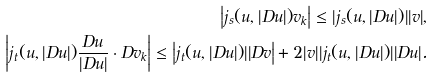Convert formula to latex. <formula><loc_0><loc_0><loc_500><loc_500>\left | j _ { s } ( u , | D u | ) v _ { k } \right | \leq | j _ { s } ( u , | D u | ) | | v | , \\ \left | j _ { t } ( u , | D u | ) \frac { D u } { | D u | } \cdot D v _ { k } \right | \leq \left | j _ { t } ( u , | D u | ) | | D v \right | + 2 | v | | j _ { t } ( u , | D u | ) | | D u | .</formula> 